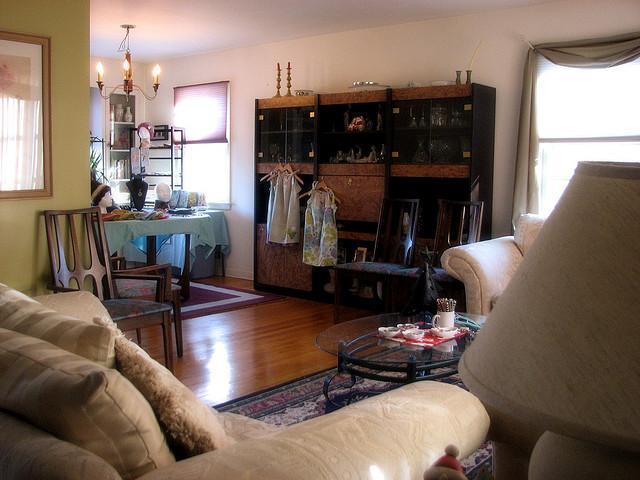Why are the clothes on hangers?
Make your selection from the four choices given to correctly answer the question.
Options: For sale, hiding, airing out, cleaning. Airing out. 